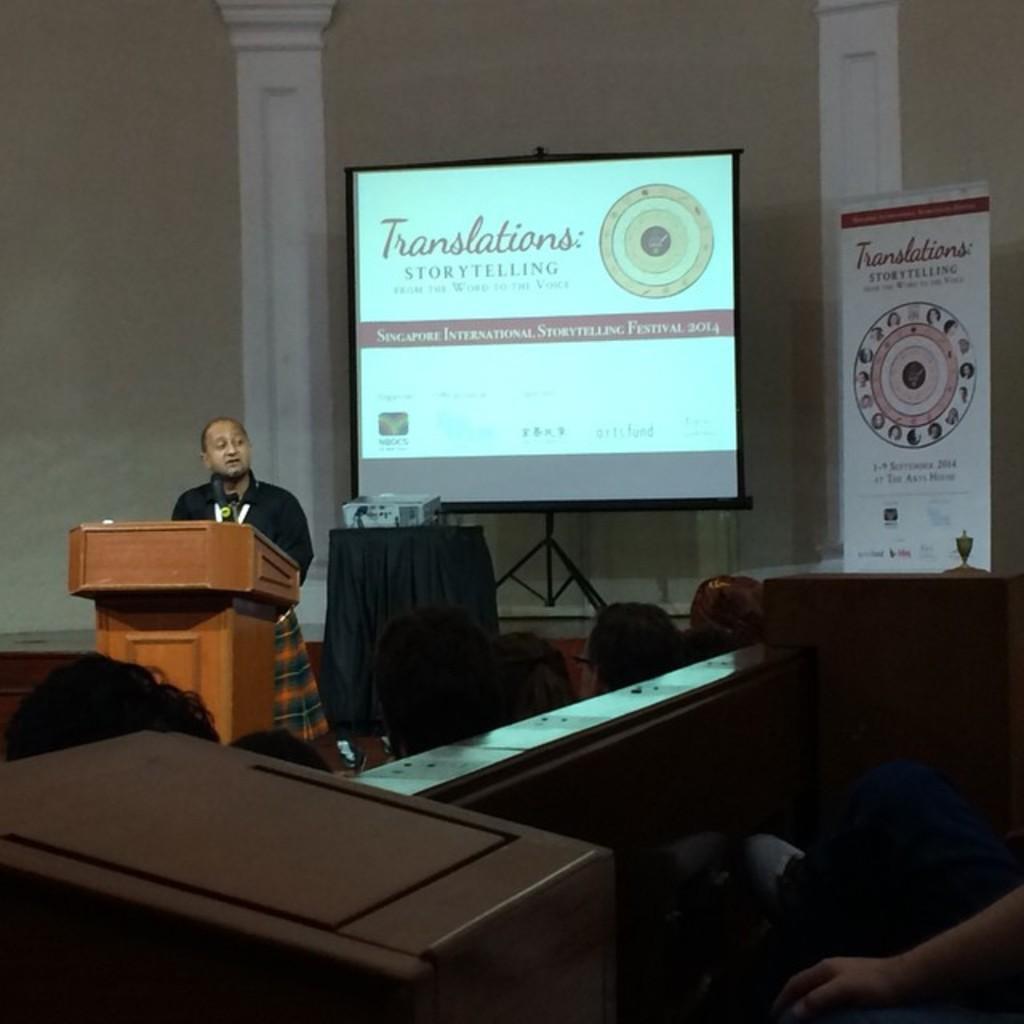Can you describe this image briefly? In this image I can see a man standing in front of a podium. Here also I can see few people. In the background I can see projector and projector screen. 